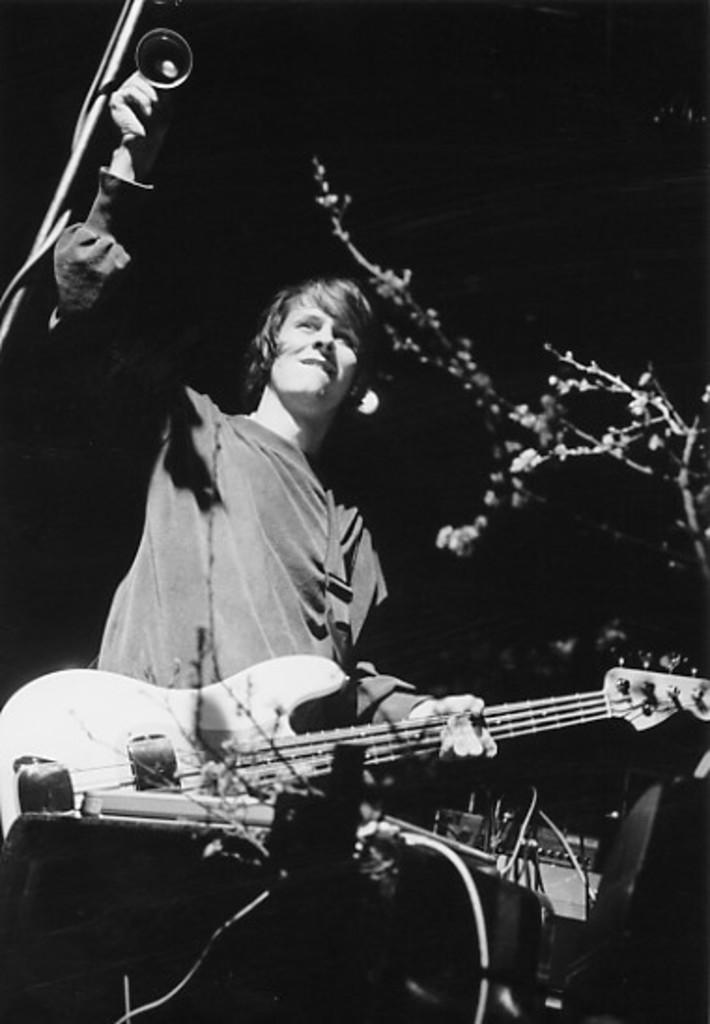What is the main subject of the image? There is a person in the image. What is the person holding in his hand? The person is holding a guitar in his hand. Can you see a river flowing in the background of the image? There is no river visible in the image; it only features a person holding a guitar. Is there a stem attached to the guitar in the image? There is no stem present on the guitar in the image. 